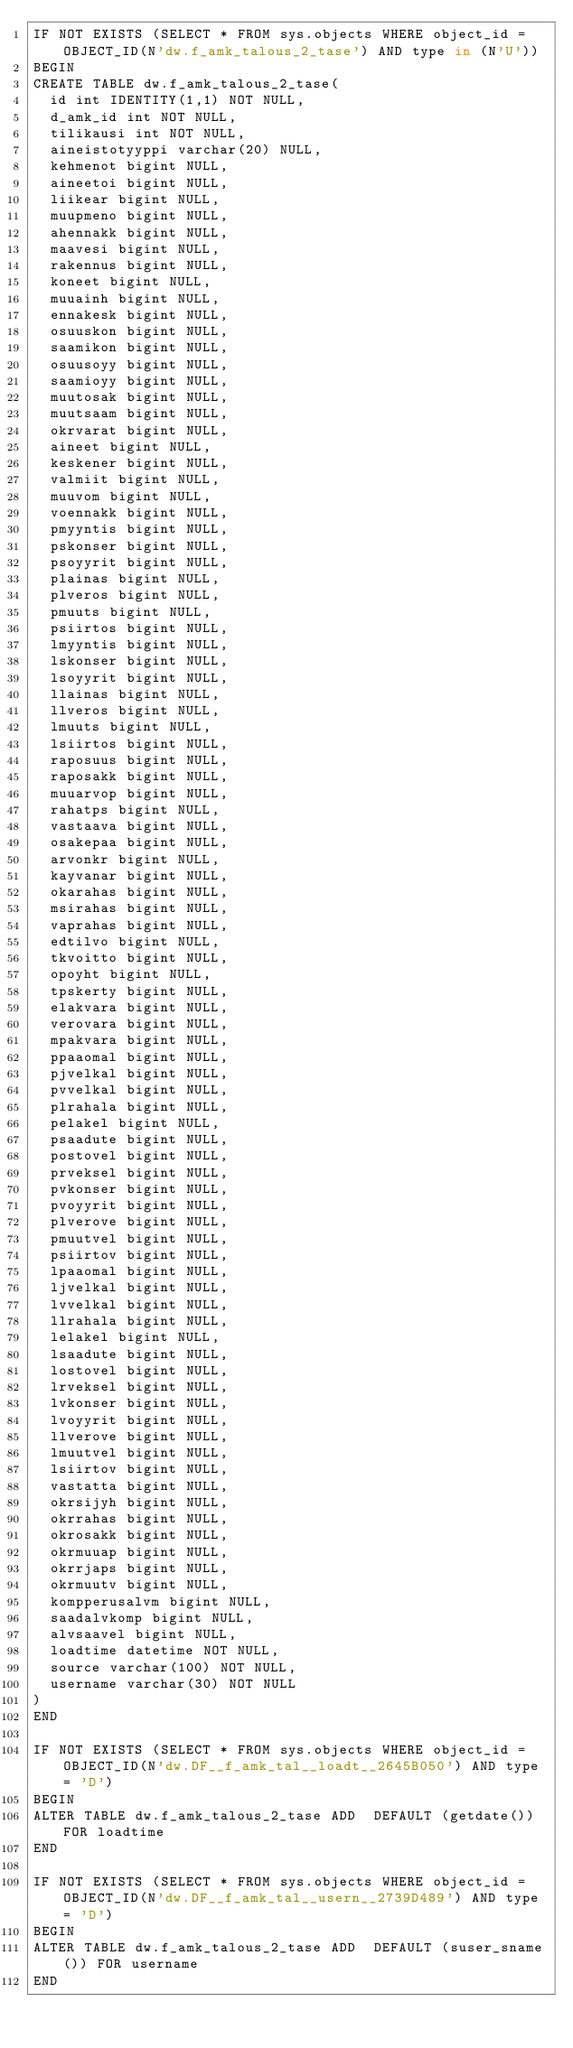<code> <loc_0><loc_0><loc_500><loc_500><_SQL_>IF NOT EXISTS (SELECT * FROM sys.objects WHERE object_id = OBJECT_ID(N'dw.f_amk_talous_2_tase') AND type in (N'U'))
BEGIN
CREATE TABLE dw.f_amk_talous_2_tase(
  id int IDENTITY(1,1) NOT NULL,
  d_amk_id int NOT NULL,
  tilikausi int NOT NULL,
  aineistotyyppi varchar(20) NULL,
  kehmenot bigint NULL,
  aineetoi bigint NULL,
  liikear bigint NULL,
  muupmeno bigint NULL,
  ahennakk bigint NULL,
  maavesi bigint NULL,
  rakennus bigint NULL,
  koneet bigint NULL,
  muuainh bigint NULL,
  ennakesk bigint NULL,
  osuuskon bigint NULL,
  saamikon bigint NULL,
  osuusoyy bigint NULL,
  saamioyy bigint NULL,
  muutosak bigint NULL,
  muutsaam bigint NULL,
  okrvarat bigint NULL,
  aineet bigint NULL,
  keskener bigint NULL,
  valmiit bigint NULL,
  muuvom bigint NULL,
  voennakk bigint NULL,
  pmyyntis bigint NULL,
  pskonser bigint NULL,
  psoyyrit bigint NULL,
  plainas bigint NULL,
  plveros bigint NULL,
  pmuuts bigint NULL,
  psiirtos bigint NULL,
  lmyyntis bigint NULL,
  lskonser bigint NULL,
  lsoyyrit bigint NULL,
  llainas bigint NULL,
  llveros bigint NULL,
  lmuuts bigint NULL,
  lsiirtos bigint NULL,
  raposuus bigint NULL,
  raposakk bigint NULL,
  muuarvop bigint NULL,
  rahatps bigint NULL,
  vastaava bigint NULL,
  osakepaa bigint NULL,
  arvonkr bigint NULL,
  kayvanar bigint NULL,
  okarahas bigint NULL,
  msirahas bigint NULL,
  vaprahas bigint NULL,
  edtilvo bigint NULL,
  tkvoitto bigint NULL,
  opoyht bigint NULL,
  tpskerty bigint NULL,
  elakvara bigint NULL,
  verovara bigint NULL,
  mpakvara bigint NULL,
  ppaaomal bigint NULL,
  pjvelkal bigint NULL,
  pvvelkal bigint NULL,
  plrahala bigint NULL,
  pelakel bigint NULL,
  psaadute bigint NULL,
  postovel bigint NULL,
  prveksel bigint NULL,
  pvkonser bigint NULL,
  pvoyyrit bigint NULL,
  plverove bigint NULL,
  pmuutvel bigint NULL,
  psiirtov bigint NULL,
  lpaaomal bigint NULL,
  ljvelkal bigint NULL,
  lvvelkal bigint NULL,
  llrahala bigint NULL,
  lelakel bigint NULL,
  lsaadute bigint NULL,
  lostovel bigint NULL,
  lrveksel bigint NULL,
  lvkonser bigint NULL,
  lvoyyrit bigint NULL,
  llverove bigint NULL,
  lmuutvel bigint NULL,
  lsiirtov bigint NULL,
  vastatta bigint NULL,
  okrsijyh bigint NULL,
  okrrahas bigint NULL,
  okrosakk bigint NULL,
  okrmuuap bigint NULL,
  okrrjaps bigint NULL,
  okrmuutv bigint NULL,
  kompperusalvm bigint NULL,
  saadalvkomp bigint NULL,
  alvsaavel bigint NULL,
  loadtime datetime NOT NULL,
  source varchar(100) NOT NULL,
  username varchar(30) NOT NULL
)
END

IF NOT EXISTS (SELECT * FROM sys.objects WHERE object_id = OBJECT_ID(N'dw.DF__f_amk_tal__loadt__2645B050') AND type = 'D')
BEGIN
ALTER TABLE dw.f_amk_talous_2_tase ADD  DEFAULT (getdate()) FOR loadtime
END

IF NOT EXISTS (SELECT * FROM sys.objects WHERE object_id = OBJECT_ID(N'dw.DF__f_amk_tal__usern__2739D489') AND type = 'D')
BEGIN
ALTER TABLE dw.f_amk_talous_2_tase ADD  DEFAULT (suser_sname()) FOR username
END</code> 